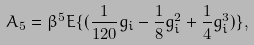Convert formula to latex. <formula><loc_0><loc_0><loc_500><loc_500>A _ { 5 } = \beta ^ { 5 } E \{ ( \frac { 1 } { 1 2 0 } g _ { i } - \frac { 1 } { 8 } g _ { i } ^ { 2 } + \frac { 1 } { 4 } g _ { i } ^ { 3 } ) \} ,</formula> 